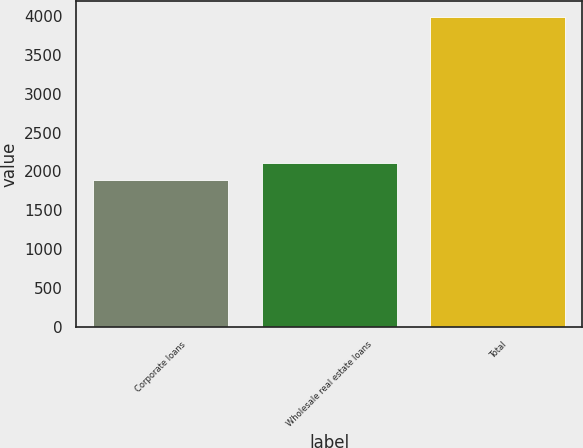<chart> <loc_0><loc_0><loc_500><loc_500><bar_chart><fcel>Corporate loans<fcel>Wholesale real estate loans<fcel>Total<nl><fcel>1884<fcel>2112<fcel>3996<nl></chart> 